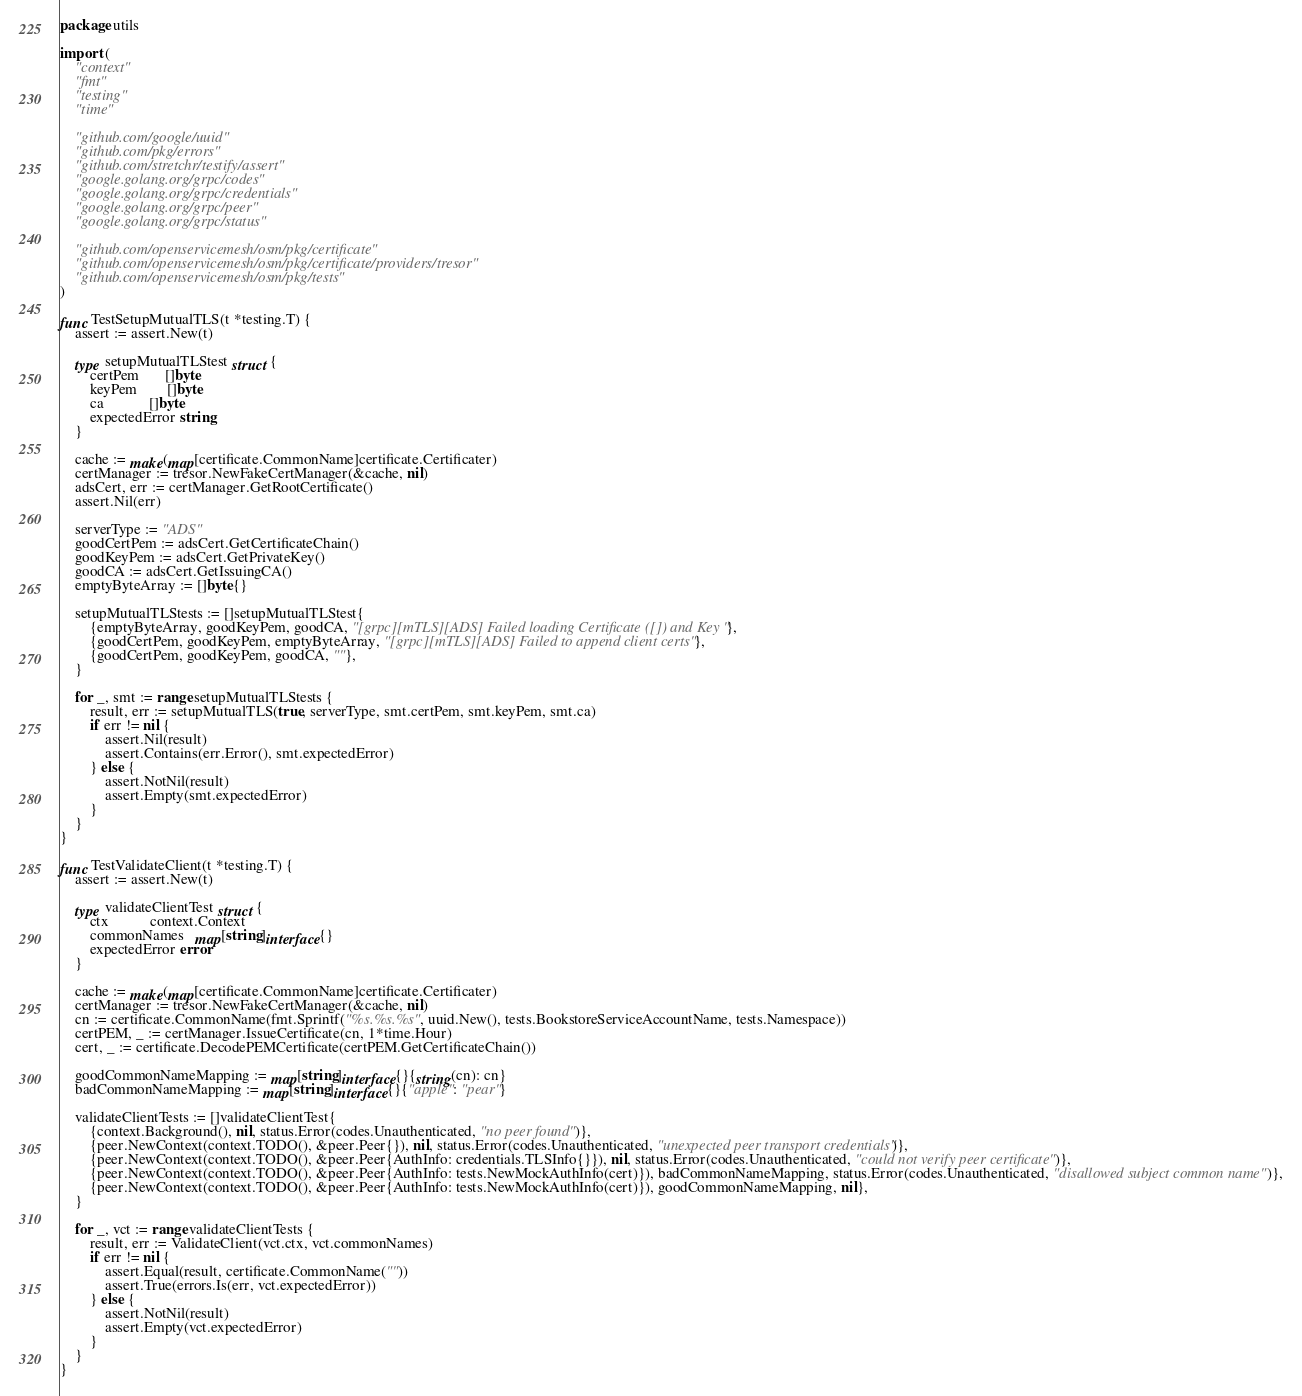Convert code to text. <code><loc_0><loc_0><loc_500><loc_500><_Go_>package utils

import (
	"context"
	"fmt"
	"testing"
	"time"

	"github.com/google/uuid"
	"github.com/pkg/errors"
	"github.com/stretchr/testify/assert"
	"google.golang.org/grpc/codes"
	"google.golang.org/grpc/credentials"
	"google.golang.org/grpc/peer"
	"google.golang.org/grpc/status"

	"github.com/openservicemesh/osm/pkg/certificate"
	"github.com/openservicemesh/osm/pkg/certificate/providers/tresor"
	"github.com/openservicemesh/osm/pkg/tests"
)

func TestSetupMutualTLS(t *testing.T) {
	assert := assert.New(t)

	type setupMutualTLStest struct {
		certPem       []byte
		keyPem        []byte
		ca            []byte
		expectedError string
	}

	cache := make(map[certificate.CommonName]certificate.Certificater)
	certManager := tresor.NewFakeCertManager(&cache, nil)
	adsCert, err := certManager.GetRootCertificate()
	assert.Nil(err)

	serverType := "ADS"
	goodCertPem := adsCert.GetCertificateChain()
	goodKeyPem := adsCert.GetPrivateKey()
	goodCA := adsCert.GetIssuingCA()
	emptyByteArray := []byte{}

	setupMutualTLStests := []setupMutualTLStest{
		{emptyByteArray, goodKeyPem, goodCA, "[grpc][mTLS][ADS] Failed loading Certificate ([]) and Key "},
		{goodCertPem, goodKeyPem, emptyByteArray, "[grpc][mTLS][ADS] Failed to append client certs"},
		{goodCertPem, goodKeyPem, goodCA, ""},
	}

	for _, smt := range setupMutualTLStests {
		result, err := setupMutualTLS(true, serverType, smt.certPem, smt.keyPem, smt.ca)
		if err != nil {
			assert.Nil(result)
			assert.Contains(err.Error(), smt.expectedError)
		} else {
			assert.NotNil(result)
			assert.Empty(smt.expectedError)
		}
	}
}

func TestValidateClient(t *testing.T) {
	assert := assert.New(t)

	type validateClientTest struct {
		ctx           context.Context
		commonNames   map[string]interface{}
		expectedError error
	}

	cache := make(map[certificate.CommonName]certificate.Certificater)
	certManager := tresor.NewFakeCertManager(&cache, nil)
	cn := certificate.CommonName(fmt.Sprintf("%s.%s.%s", uuid.New(), tests.BookstoreServiceAccountName, tests.Namespace))
	certPEM, _ := certManager.IssueCertificate(cn, 1*time.Hour)
	cert, _ := certificate.DecodePEMCertificate(certPEM.GetCertificateChain())

	goodCommonNameMapping := map[string]interface{}{string(cn): cn}
	badCommonNameMapping := map[string]interface{}{"apple": "pear"}

	validateClientTests := []validateClientTest{
		{context.Background(), nil, status.Error(codes.Unauthenticated, "no peer found")},
		{peer.NewContext(context.TODO(), &peer.Peer{}), nil, status.Error(codes.Unauthenticated, "unexpected peer transport credentials")},
		{peer.NewContext(context.TODO(), &peer.Peer{AuthInfo: credentials.TLSInfo{}}), nil, status.Error(codes.Unauthenticated, "could not verify peer certificate")},
		{peer.NewContext(context.TODO(), &peer.Peer{AuthInfo: tests.NewMockAuthInfo(cert)}), badCommonNameMapping, status.Error(codes.Unauthenticated, "disallowed subject common name")},
		{peer.NewContext(context.TODO(), &peer.Peer{AuthInfo: tests.NewMockAuthInfo(cert)}), goodCommonNameMapping, nil},
	}

	for _, vct := range validateClientTests {
		result, err := ValidateClient(vct.ctx, vct.commonNames)
		if err != nil {
			assert.Equal(result, certificate.CommonName(""))
			assert.True(errors.Is(err, vct.expectedError))
		} else {
			assert.NotNil(result)
			assert.Empty(vct.expectedError)
		}
	}
}
</code> 